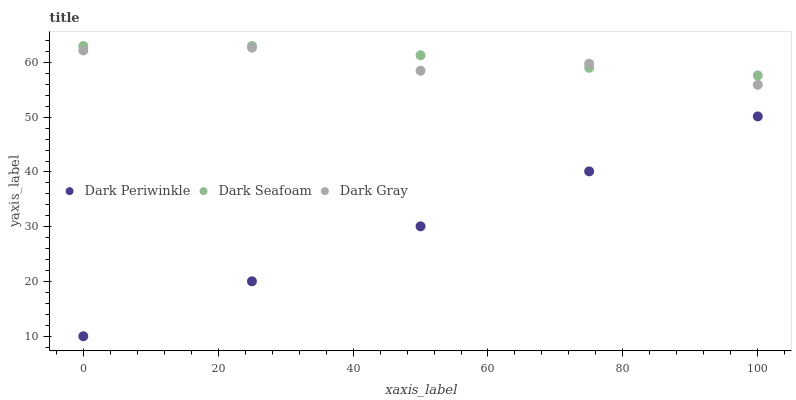Does Dark Periwinkle have the minimum area under the curve?
Answer yes or no. Yes. Does Dark Seafoam have the maximum area under the curve?
Answer yes or no. Yes. Does Dark Seafoam have the minimum area under the curve?
Answer yes or no. No. Does Dark Periwinkle have the maximum area under the curve?
Answer yes or no. No. Is Dark Periwinkle the smoothest?
Answer yes or no. Yes. Is Dark Gray the roughest?
Answer yes or no. Yes. Is Dark Seafoam the smoothest?
Answer yes or no. No. Is Dark Seafoam the roughest?
Answer yes or no. No. Does Dark Periwinkle have the lowest value?
Answer yes or no. Yes. Does Dark Seafoam have the lowest value?
Answer yes or no. No. Does Dark Seafoam have the highest value?
Answer yes or no. Yes. Does Dark Periwinkle have the highest value?
Answer yes or no. No. Is Dark Periwinkle less than Dark Gray?
Answer yes or no. Yes. Is Dark Gray greater than Dark Periwinkle?
Answer yes or no. Yes. Does Dark Seafoam intersect Dark Gray?
Answer yes or no. Yes. Is Dark Seafoam less than Dark Gray?
Answer yes or no. No. Is Dark Seafoam greater than Dark Gray?
Answer yes or no. No. Does Dark Periwinkle intersect Dark Gray?
Answer yes or no. No. 